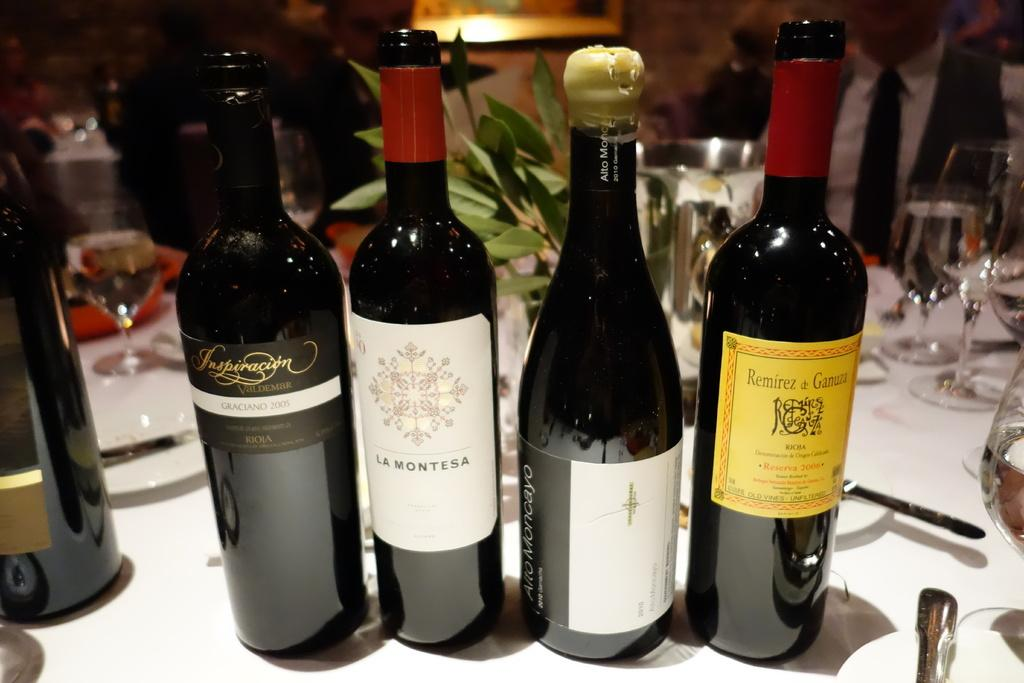<image>
Describe the image concisely. A bottle has a La Montesa label on it and has other bottles around it. 